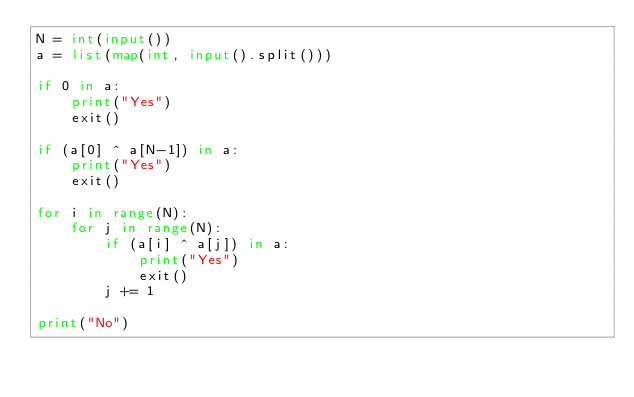<code> <loc_0><loc_0><loc_500><loc_500><_Python_>N = int(input())
a = list(map(int, input().split()))

if 0 in a:
    print("Yes")
    exit()

if (a[0] ^ a[N-1]) in a:
    print("Yes")
    exit()

for i in range(N):
    for j in range(N):
        if (a[i] ^ a[j]) in a:
            print("Yes")
            exit()
        j += 1

print("No")</code> 